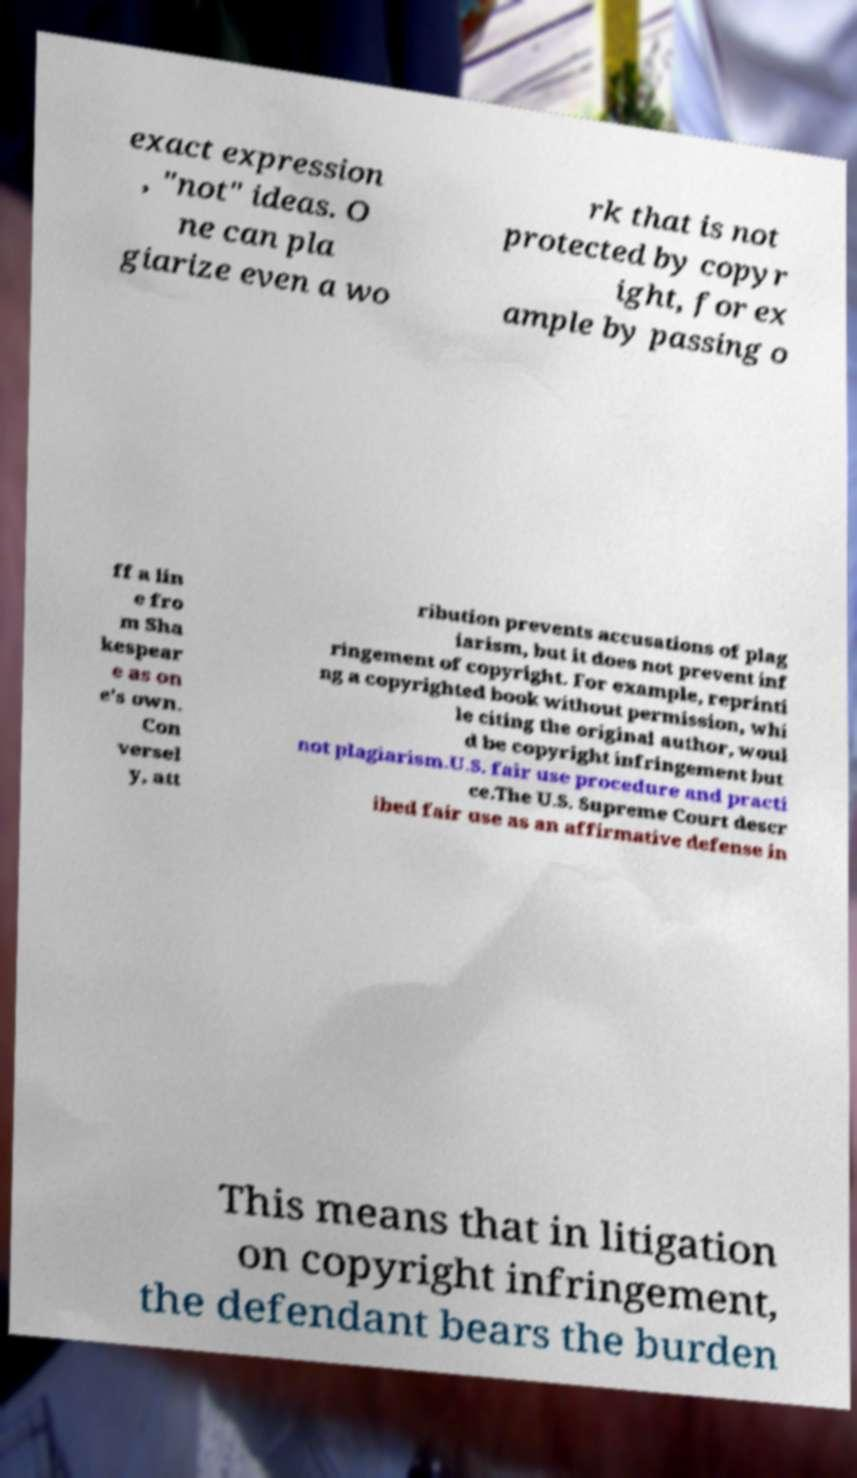Please identify and transcribe the text found in this image. exact expression , "not" ideas. O ne can pla giarize even a wo rk that is not protected by copyr ight, for ex ample by passing o ff a lin e fro m Sha kespear e as on e's own. Con versel y, att ribution prevents accusations of plag iarism, but it does not prevent inf ringement of copyright. For example, reprinti ng a copyrighted book without permission, whi le citing the original author, woul d be copyright infringement but not plagiarism.U.S. fair use procedure and practi ce.The U.S. Supreme Court descr ibed fair use as an affirmative defense in This means that in litigation on copyright infringement, the defendant bears the burden 